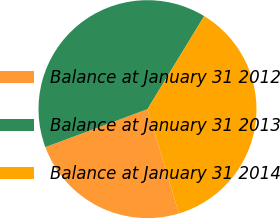Convert chart. <chart><loc_0><loc_0><loc_500><loc_500><pie_chart><fcel>Balance at January 31 2012<fcel>Balance at January 31 2013<fcel>Balance at January 31 2014<nl><fcel>23.99%<fcel>39.38%<fcel>36.63%<nl></chart> 